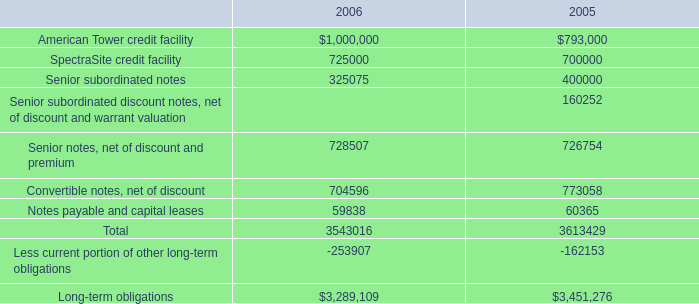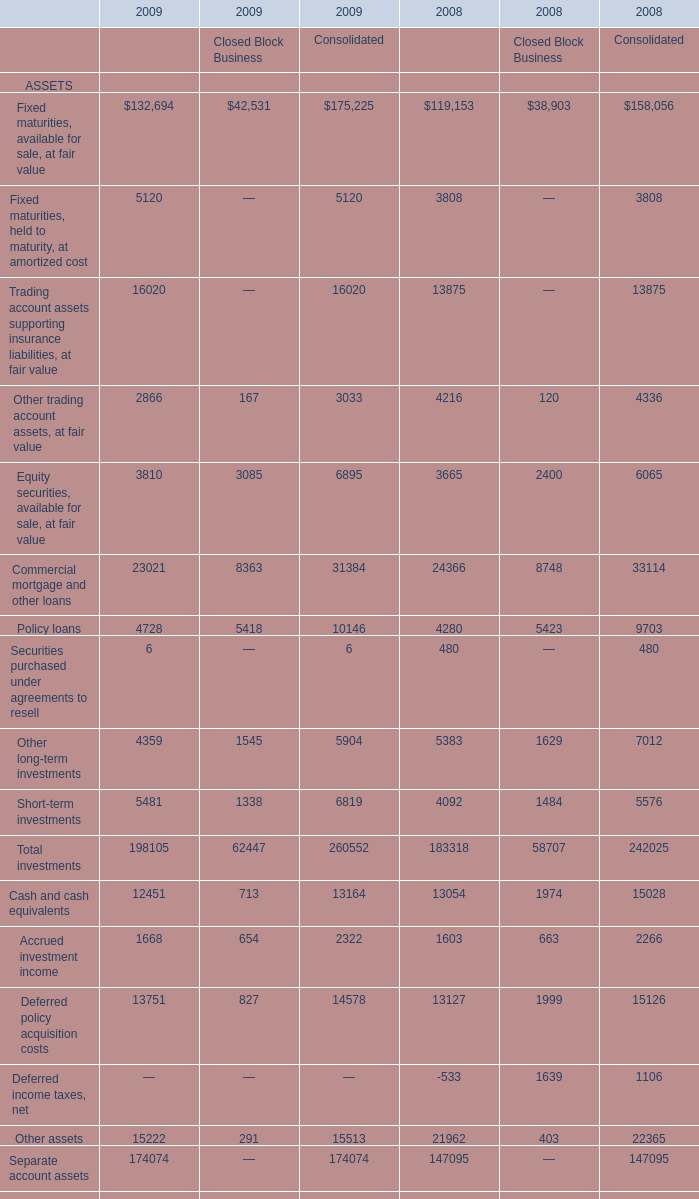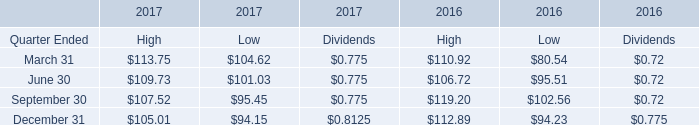What is the average amount of SpectraSite credit facility of 2006, and Accrued investment income of 2009 Consolidated ? 
Computations: ((725000.0 + 2322.0) / 2)
Answer: 363661.0. 